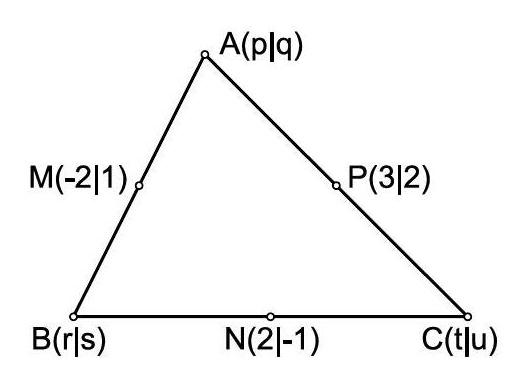How does knowledge of the midpoints help in solving other properties of the triangle, such as area or angles? Knowing the midpoints allows for computation of the triangle's sides by deriving the distances between vertices using their coordinates. From there, you can apply Heron's formula to calculate the area of the triangle. Additionally, using the Law of Cosines, you can calculate the angles of the triangle, providing a comprehensive understanding of its geometric properties. 